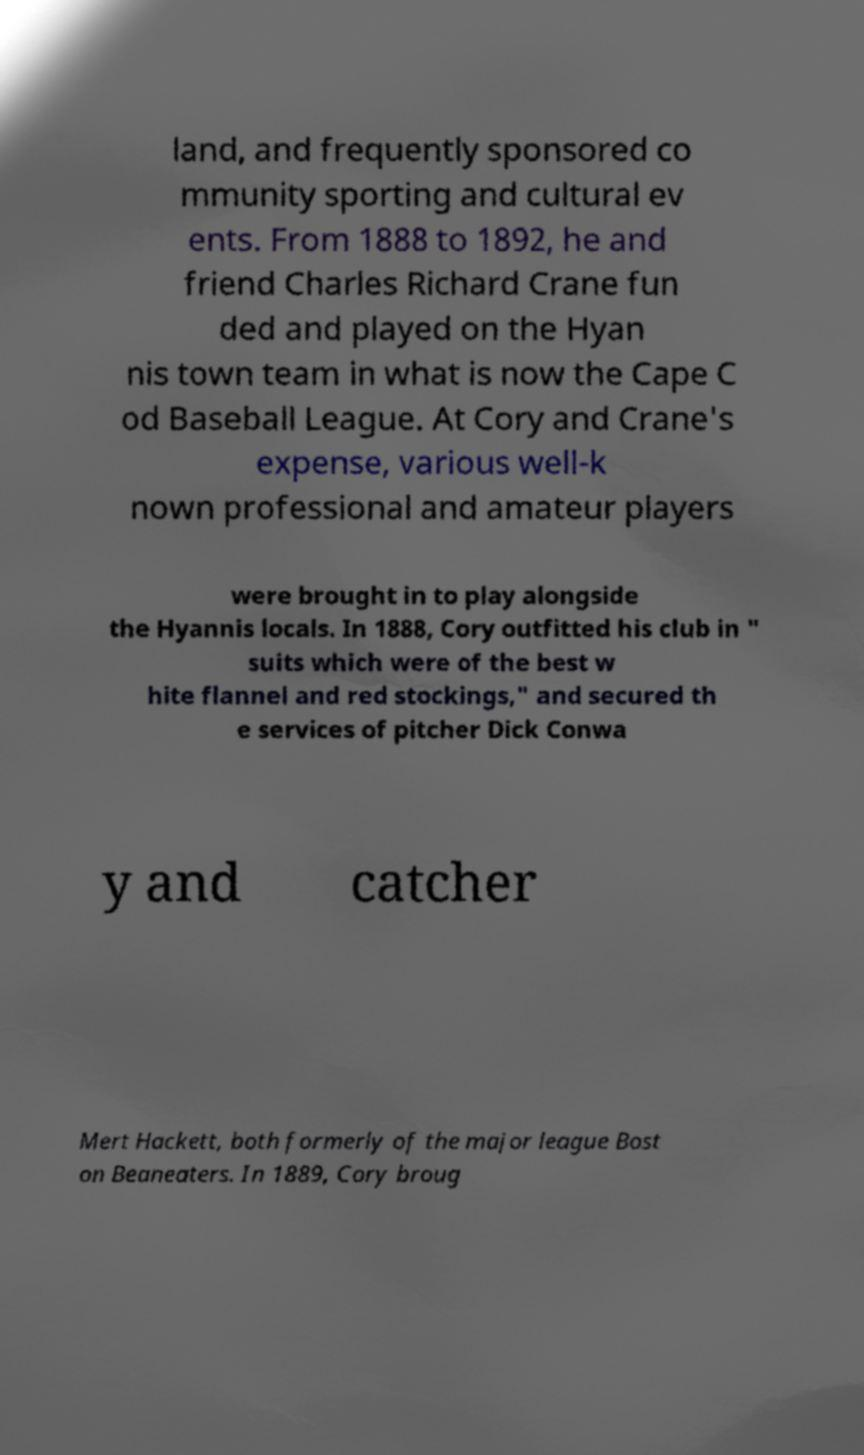Can you read and provide the text displayed in the image?This photo seems to have some interesting text. Can you extract and type it out for me? land, and frequently sponsored co mmunity sporting and cultural ev ents. From 1888 to 1892, he and friend Charles Richard Crane fun ded and played on the Hyan nis town team in what is now the Cape C od Baseball League. At Cory and Crane's expense, various well-k nown professional and amateur players were brought in to play alongside the Hyannis locals. In 1888, Cory outfitted his club in " suits which were of the best w hite flannel and red stockings," and secured th e services of pitcher Dick Conwa y and catcher Mert Hackett, both formerly of the major league Bost on Beaneaters. In 1889, Cory broug 